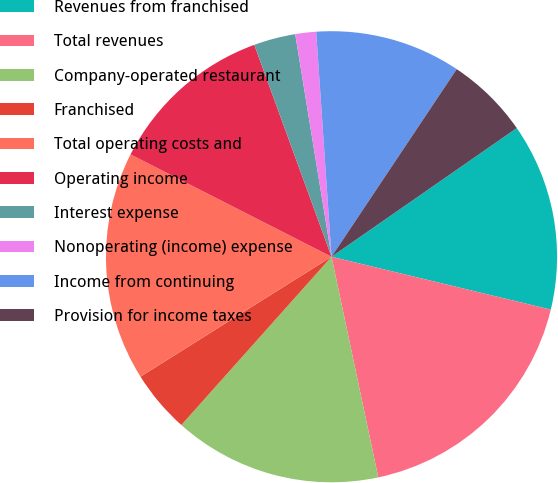<chart> <loc_0><loc_0><loc_500><loc_500><pie_chart><fcel>Revenues from franchised<fcel>Total revenues<fcel>Company-operated restaurant<fcel>Franchised<fcel>Total operating costs and<fcel>Operating income<fcel>Interest expense<fcel>Nonoperating (income) expense<fcel>Income from continuing<fcel>Provision for income taxes<nl><fcel>13.43%<fcel>17.91%<fcel>14.92%<fcel>4.48%<fcel>16.42%<fcel>11.94%<fcel>2.99%<fcel>1.49%<fcel>10.45%<fcel>5.97%<nl></chart> 